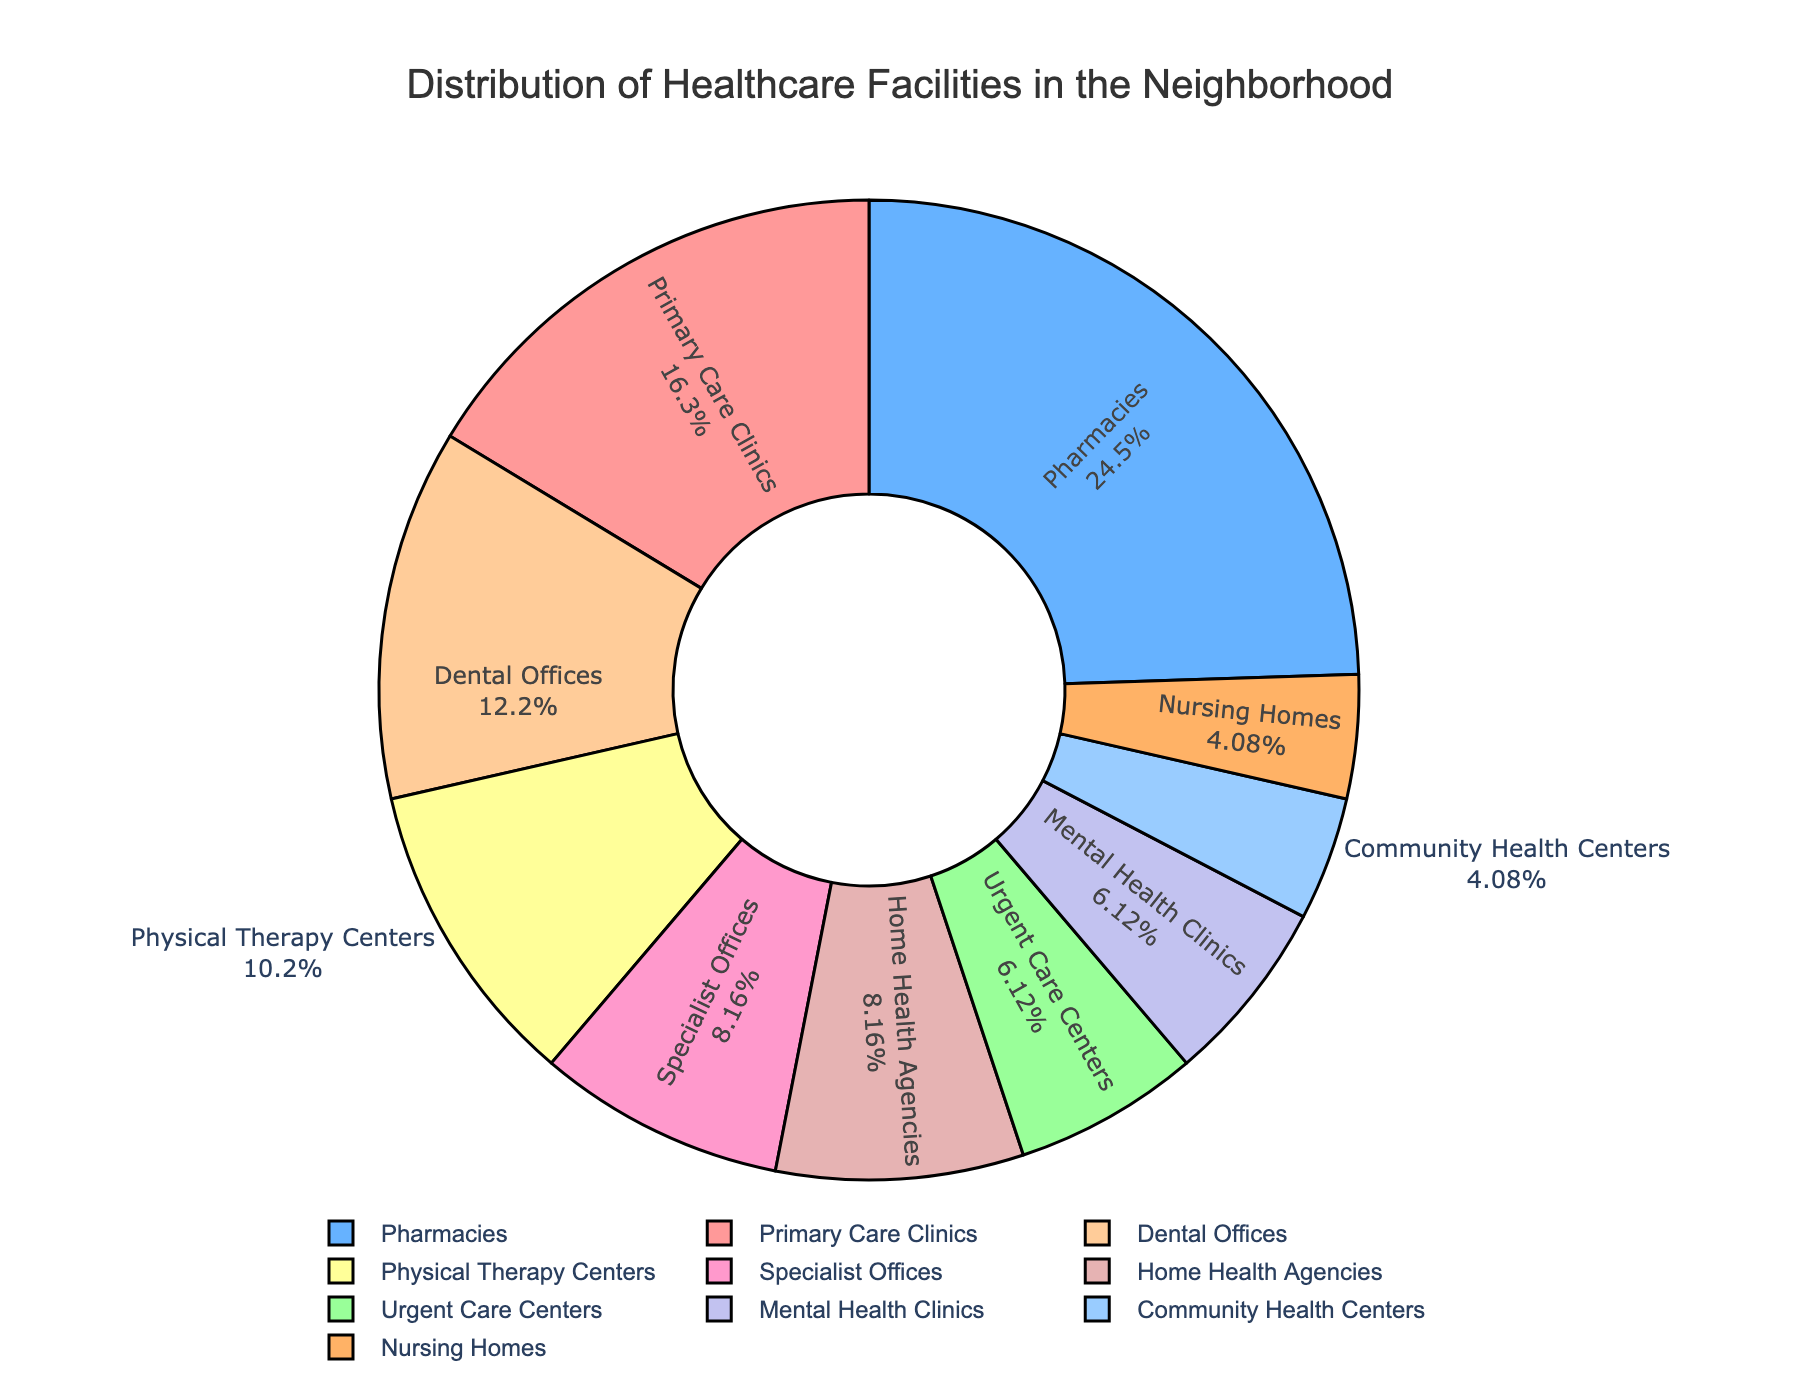Which type of healthcare facility is the most common? The figure shows different sectors of a pie chart with labels and percentages. The largest sector represents the most common facility.
Answer: Pharmacies How many Primary Care Clinics and Specialist Offices are there in total? Count the individual numbers for Primary Care Clinics and Specialist Offices and sum them up: 8 + 4 = 12.
Answer: 12 What percentage of the healthcare facilities are Mental Health Clinics? Determine the slice of the pie chart labeled "Mental Health Clinics" and read the percentage shown.
Answer: 8.3% Are there more Dental Offices or Physical Therapy Centers? Compare the number of Dental Offices and Physical Therapy Centers using the pie chart.
Answer: Dental Offices What is the combined percentage of Community Health Centers and Nursing Homes? Add the percentages of the slices labeled "Community Health Centers" and "Nursing Homes".
Answer: 4.2% + 4.2% = 8.4% Which color represents the Primary Care Clinics? Identify the slice labeled "Primary Care Clinics" and note its color.
Answer: Red Are Urgent Care Centers or Home Health Agencies more frequent in the neighborhood? Compare the number of facilities labeled "Urgent Care Centers" and "Home Health Agencies" from the pie chart.
Answer: Home Health Agencies What is the difference in the number of Pharmacies and Mental Health Clinics? Subtract the number of Mental Health Clinics from the number of Pharmacies: 12 - 3 = 9.
Answer: 9 Which facility type comprises exactly 8.3% of the total healthcare facilities? Look at the pie chart for the slice that has "8.3%" within it.
Answer: Mental Health Clinics What percentage of facilities are Specialist Offices and Home Health Agencies combined? Add the percentages of the slices labeled "Specialist Offices" and "Home Health Agencies".
Answer: 11.1% + 11.1% = 22.2% 